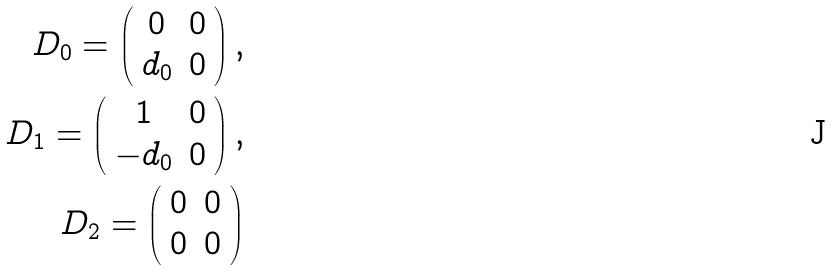Convert formula to latex. <formula><loc_0><loc_0><loc_500><loc_500>D _ { 0 } = \left ( \begin{array} { c c } 0 & 0 \\ d _ { 0 } & 0 \\ \end{array} \right ) , \\ D _ { 1 } = \left ( \begin{array} { c c } 1 & 0 \\ - d _ { 0 } & 0 \\ \end{array} \right ) , \\ D _ { 2 } = \left ( \begin{array} { c c } 0 & 0 \\ 0 & 0 \\ \end{array} \right )</formula> 